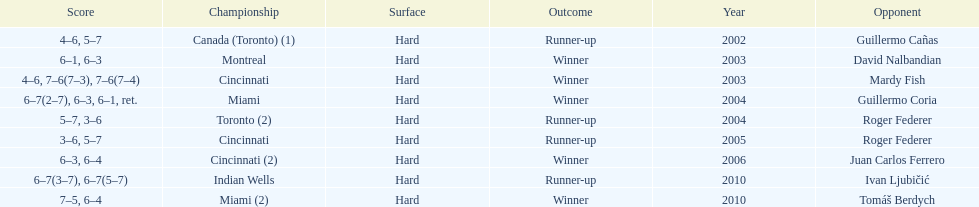Was roddick a runner-up or winner more? Winner. Give me the full table as a dictionary. {'header': ['Score', 'Championship', 'Surface', 'Outcome', 'Year', 'Opponent'], 'rows': [['4–6, 5–7', 'Canada (Toronto) (1)', 'Hard', 'Runner-up', '2002', 'Guillermo Cañas'], ['6–1, 6–3', 'Montreal', 'Hard', 'Winner', '2003', 'David Nalbandian'], ['4–6, 7–6(7–3), 7–6(7–4)', 'Cincinnati', 'Hard', 'Winner', '2003', 'Mardy Fish'], ['6–7(2–7), 6–3, 6–1, ret.', 'Miami', 'Hard', 'Winner', '2004', 'Guillermo Coria'], ['5–7, 3–6', 'Toronto (2)', 'Hard', 'Runner-up', '2004', 'Roger Federer'], ['3–6, 5–7', 'Cincinnati', 'Hard', 'Runner-up', '2005', 'Roger Federer'], ['6–3, 6–4', 'Cincinnati (2)', 'Hard', 'Winner', '2006', 'Juan Carlos Ferrero'], ['6–7(3–7), 6–7(5–7)', 'Indian Wells', 'Hard', 'Runner-up', '2010', 'Ivan Ljubičić'], ['7–5, 6–4', 'Miami (2)', 'Hard', 'Winner', '2010', 'Tomáš Berdych']]} 